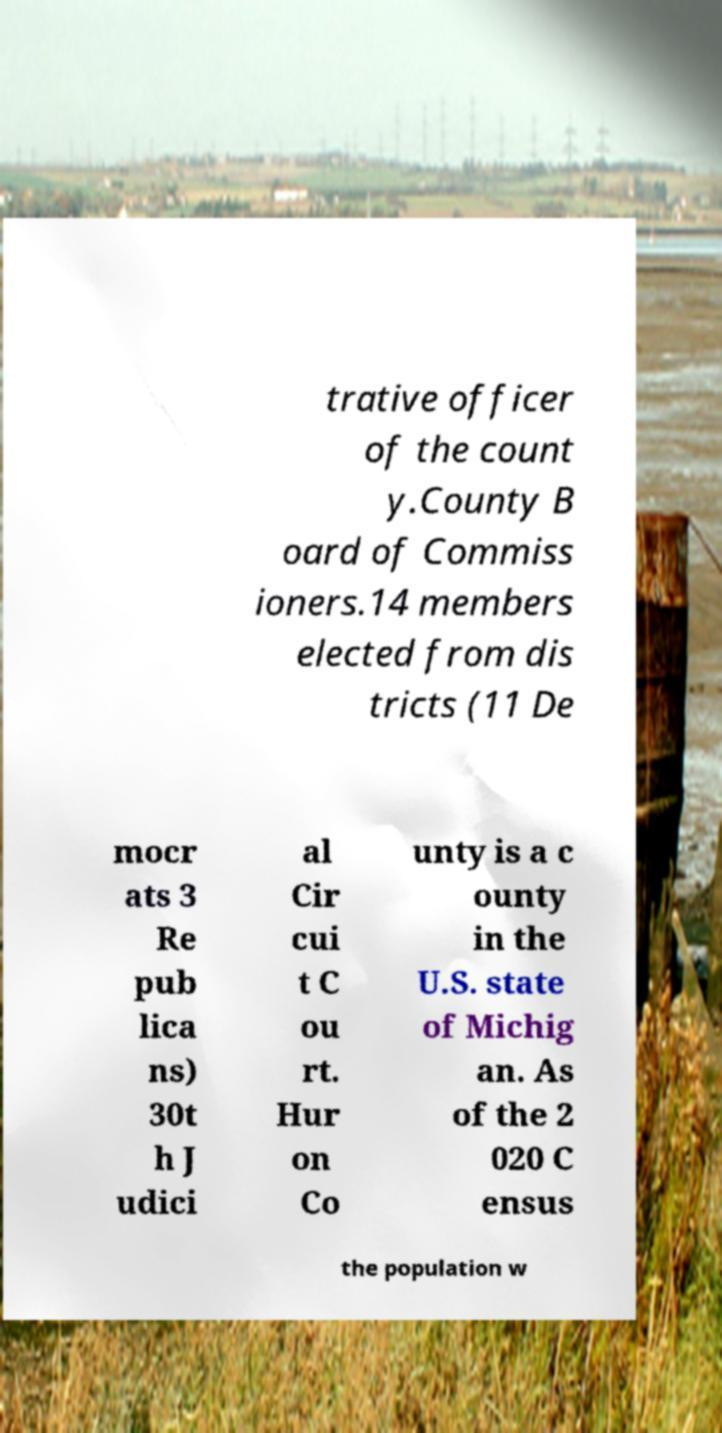Could you extract and type out the text from this image? trative officer of the count y.County B oard of Commiss ioners.14 members elected from dis tricts (11 De mocr ats 3 Re pub lica ns) 30t h J udici al Cir cui t C ou rt. Hur on Co unty is a c ounty in the U.S. state of Michig an. As of the 2 020 C ensus the population w 